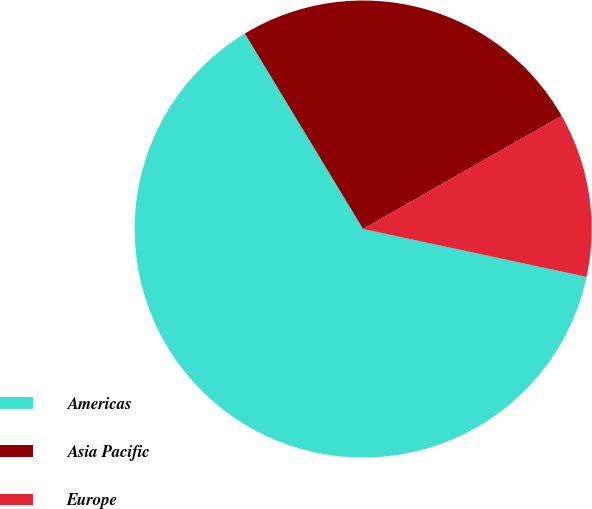Convert chart to OTSL. <chart><loc_0><loc_0><loc_500><loc_500><pie_chart><fcel>Americas<fcel>Asia Pacific<fcel>Europe<nl><fcel>62.98%<fcel>25.42%<fcel>11.6%<nl></chart> 